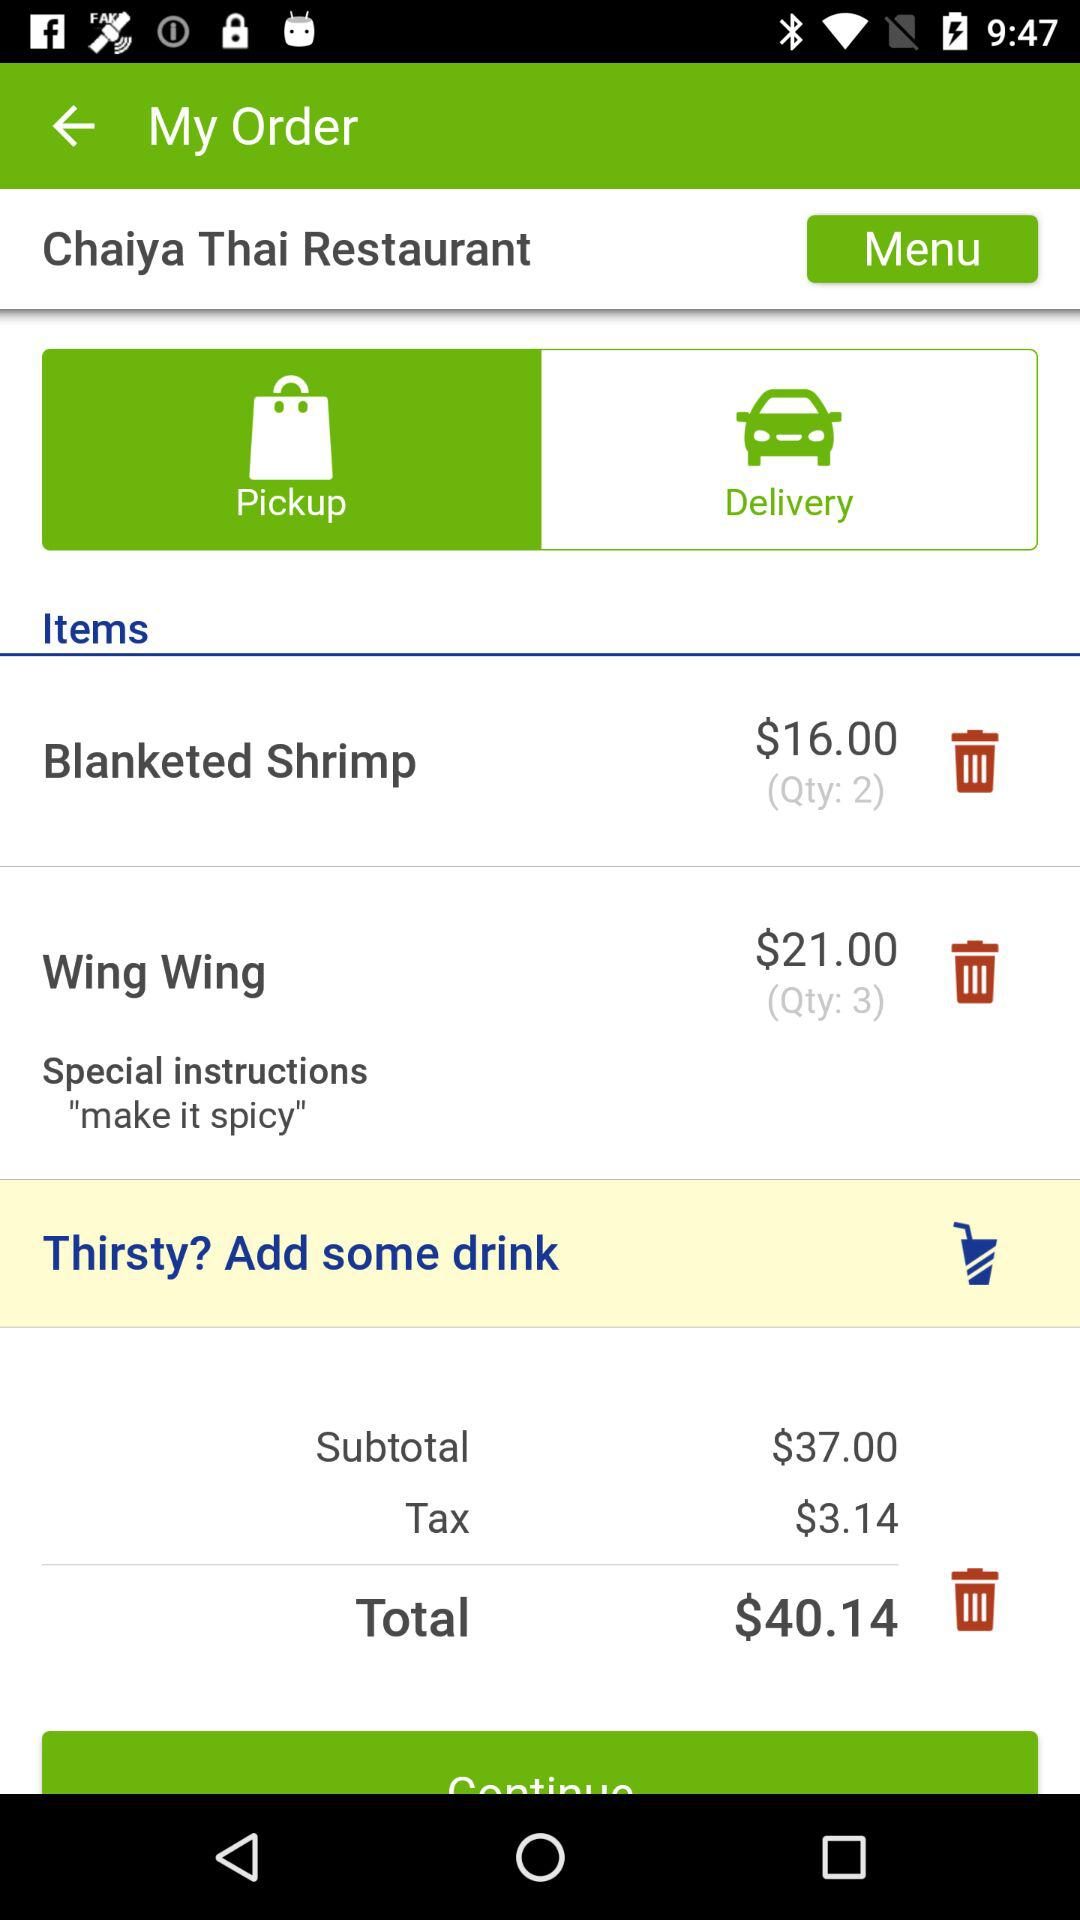How much is the price of "Blanketed Shrimp"? The price of "Blanketed Shrimp" is $16.00. 